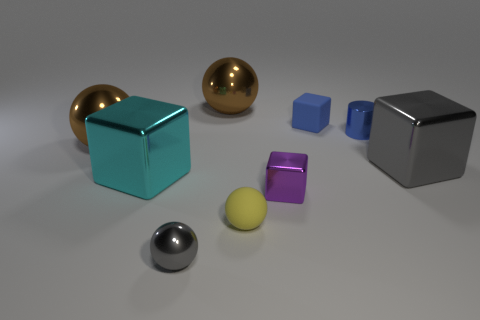Subtract all big cyan metal blocks. How many blocks are left? 3 Subtract all brown cylinders. How many brown balls are left? 2 Subtract 2 spheres. How many spheres are left? 2 Subtract all yellow spheres. How many spheres are left? 3 Subtract 0 purple cylinders. How many objects are left? 9 Subtract all balls. How many objects are left? 5 Subtract all gray cubes. Subtract all brown cylinders. How many cubes are left? 3 Subtract all small gray metallic spheres. Subtract all tiny gray spheres. How many objects are left? 7 Add 3 brown metal balls. How many brown metal balls are left? 5 Add 9 small cyan metallic cylinders. How many small cyan metallic cylinders exist? 9 